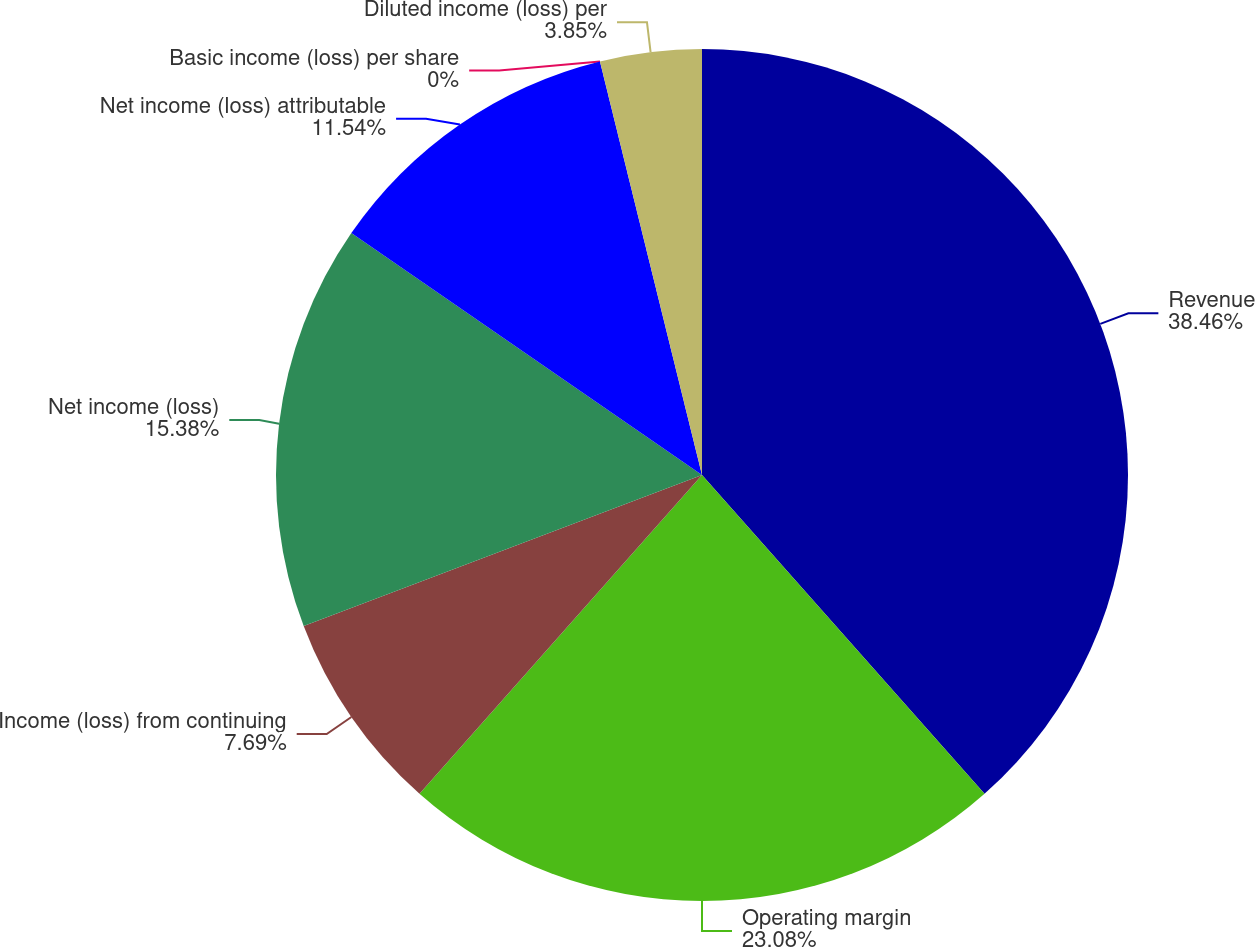<chart> <loc_0><loc_0><loc_500><loc_500><pie_chart><fcel>Revenue<fcel>Operating margin<fcel>Income (loss) from continuing<fcel>Net income (loss)<fcel>Net income (loss) attributable<fcel>Basic income (loss) per share<fcel>Diluted income (loss) per<nl><fcel>38.46%<fcel>23.08%<fcel>7.69%<fcel>15.38%<fcel>11.54%<fcel>0.0%<fcel>3.85%<nl></chart> 